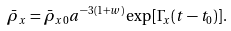<formula> <loc_0><loc_0><loc_500><loc_500>\bar { \rho } _ { x } = \bar { \rho } _ { x 0 } a ^ { - 3 ( 1 + w ) } \exp [ \Gamma _ { x } ( t - t _ { 0 } ) ] .</formula> 